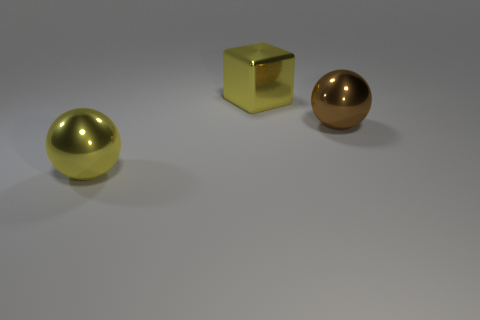There is a yellow object that is to the left of the big yellow block; is its shape the same as the big brown thing?
Your answer should be very brief. Yes. How many objects are shiny balls that are to the right of the yellow sphere or big yellow metal spheres?
Your answer should be very brief. 2. What is the shape of the brown metallic thing that is the same size as the yellow block?
Your response must be concise. Sphere. Do the sphere behind the yellow sphere and the shiny sphere to the left of the metallic cube have the same size?
Your response must be concise. Yes. The other sphere that is made of the same material as the yellow ball is what color?
Provide a short and direct response. Brown. Is the yellow thing behind the yellow metal ball made of the same material as the thing left of the shiny block?
Your answer should be compact. Yes. Are there any gray metal cylinders that have the same size as the yellow shiny ball?
Your answer should be compact. No. How big is the sphere that is right of the big shiny ball that is in front of the brown object?
Offer a very short reply. Large. What number of other blocks have the same color as the big block?
Make the answer very short. 0. What is the shape of the yellow object on the left side of the large yellow object that is on the right side of the big yellow sphere?
Your response must be concise. Sphere. 